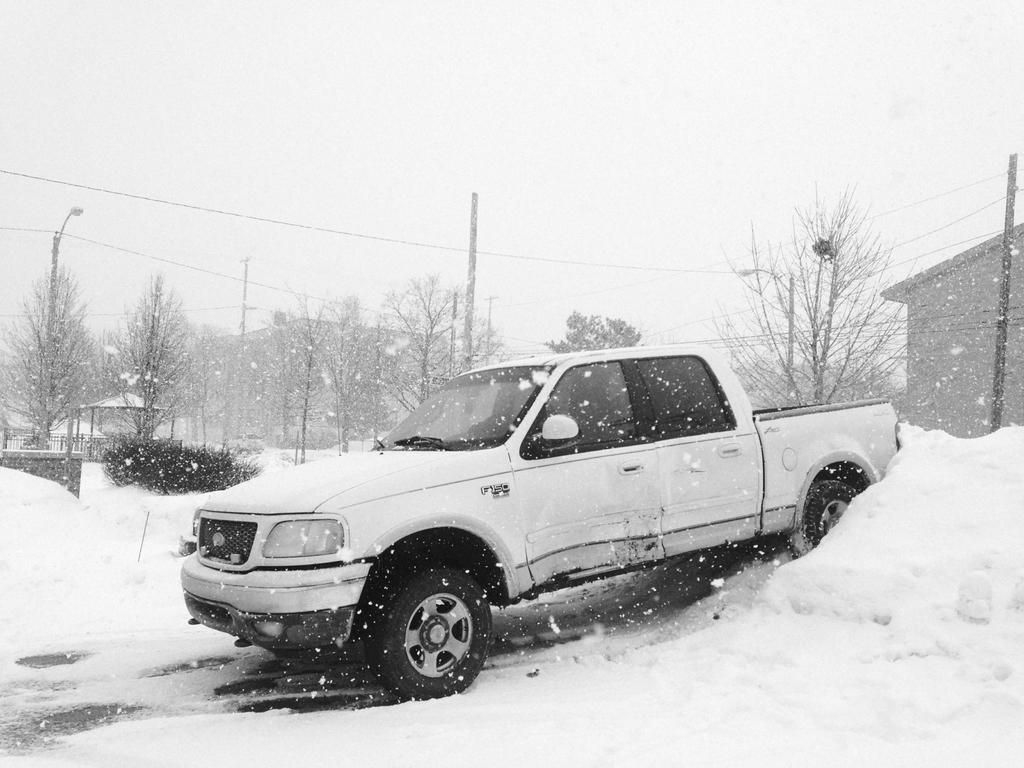What is the main subject in the center of the image? There is a vehicle in the center of the image. What is the weather condition in the image? There is snow visible in the image. What can be seen in the background of the image? There are trees in the background of the image. What structures are present in the image? There are poles and a house in the image. What channel is the vehicle tuned to in the image? There is no indication of a television or any channels in the image; it features a vehicle in the snow with trees, poles, and a house in the background. 